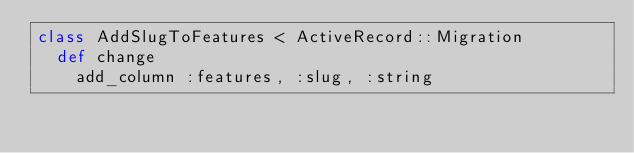<code> <loc_0><loc_0><loc_500><loc_500><_Ruby_>class AddSlugToFeatures < ActiveRecord::Migration
  def change
    add_column :features, :slug, :string</code> 